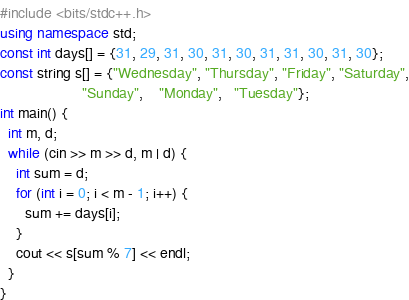<code> <loc_0><loc_0><loc_500><loc_500><_C++_>#include <bits/stdc++.h>
using namespace std;
const int days[] = {31, 29, 31, 30, 31, 30, 31, 31, 30, 31, 30};
const string s[] = {"Wednesday", "Thursday", "Friday", "Saturday",
                    "Sunday",    "Monday",   "Tuesday"};
int main() {
  int m, d;
  while (cin >> m >> d, m | d) {
    int sum = d;
    for (int i = 0; i < m - 1; i++) {
      sum += days[i];
    }
    cout << s[sum % 7] << endl;
  }
}

</code> 